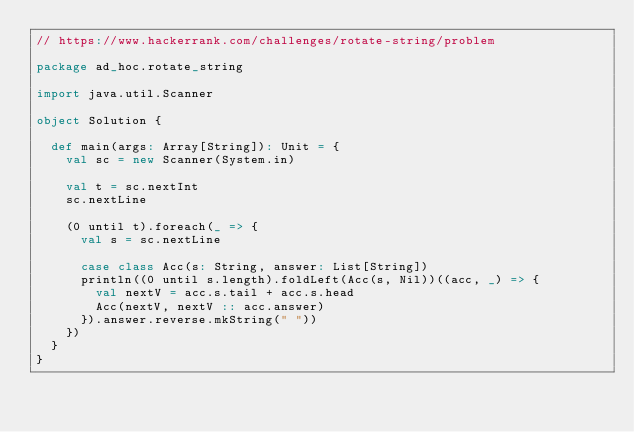<code> <loc_0><loc_0><loc_500><loc_500><_Scala_>// https://www.hackerrank.com/challenges/rotate-string/problem

package ad_hoc.rotate_string

import java.util.Scanner

object Solution {

  def main(args: Array[String]): Unit = {
    val sc = new Scanner(System.in)

    val t = sc.nextInt
    sc.nextLine

    (0 until t).foreach(_ => {
      val s = sc.nextLine

      case class Acc(s: String, answer: List[String])
      println((0 until s.length).foldLeft(Acc(s, Nil))((acc, _) => {
        val nextV = acc.s.tail + acc.s.head
        Acc(nextV, nextV :: acc.answer)
      }).answer.reverse.mkString(" "))
    })
  }
}</code> 